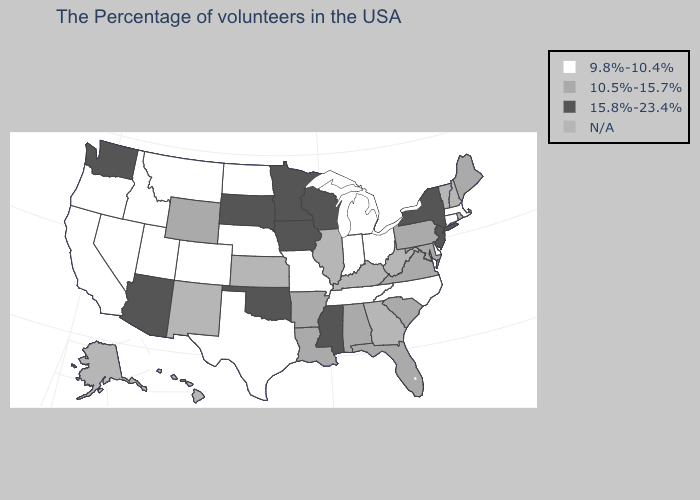Among the states that border Idaho , which have the lowest value?
Give a very brief answer. Utah, Montana, Nevada, Oregon. What is the value of Minnesota?
Answer briefly. 15.8%-23.4%. Does the map have missing data?
Keep it brief. Yes. What is the lowest value in the USA?
Keep it brief. 9.8%-10.4%. Among the states that border North Carolina , does Tennessee have the lowest value?
Be succinct. Yes. What is the value of Kentucky?
Quick response, please. N/A. Name the states that have a value in the range N/A?
Be succinct. Rhode Island, New Hampshire, Vermont, West Virginia, Georgia, Kentucky, Illinois, Kansas, New Mexico, Alaska, Hawaii. Does the map have missing data?
Short answer required. Yes. Does the map have missing data?
Keep it brief. Yes. What is the value of Maryland?
Quick response, please. 10.5%-15.7%. Does the first symbol in the legend represent the smallest category?
Give a very brief answer. Yes. Name the states that have a value in the range N/A?
Short answer required. Rhode Island, New Hampshire, Vermont, West Virginia, Georgia, Kentucky, Illinois, Kansas, New Mexico, Alaska, Hawaii. Which states have the lowest value in the Northeast?
Keep it brief. Massachusetts, Connecticut. What is the value of Tennessee?
Answer briefly. 9.8%-10.4%. 